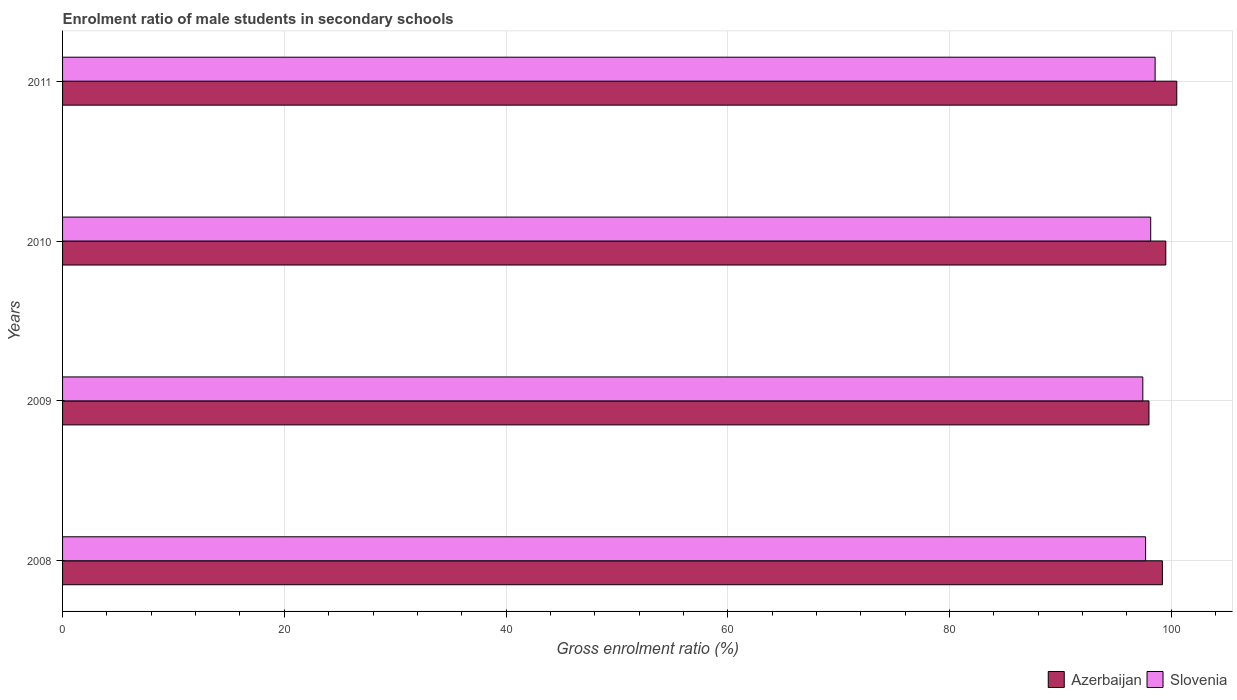How many different coloured bars are there?
Keep it short and to the point. 2. How many groups of bars are there?
Provide a succinct answer. 4. How many bars are there on the 3rd tick from the bottom?
Offer a terse response. 2. What is the label of the 4th group of bars from the top?
Offer a very short reply. 2008. What is the enrolment ratio of male students in secondary schools in Slovenia in 2010?
Offer a very short reply. 98.15. Across all years, what is the maximum enrolment ratio of male students in secondary schools in Slovenia?
Provide a short and direct response. 98.54. Across all years, what is the minimum enrolment ratio of male students in secondary schools in Slovenia?
Your response must be concise. 97.43. In which year was the enrolment ratio of male students in secondary schools in Slovenia maximum?
Offer a very short reply. 2011. What is the total enrolment ratio of male students in secondary schools in Slovenia in the graph?
Make the answer very short. 391.81. What is the difference between the enrolment ratio of male students in secondary schools in Azerbaijan in 2009 and that in 2011?
Give a very brief answer. -2.51. What is the difference between the enrolment ratio of male students in secondary schools in Slovenia in 2010 and the enrolment ratio of male students in secondary schools in Azerbaijan in 2009?
Your response must be concise. 0.16. What is the average enrolment ratio of male students in secondary schools in Azerbaijan per year?
Offer a very short reply. 99.3. In the year 2008, what is the difference between the enrolment ratio of male students in secondary schools in Azerbaijan and enrolment ratio of male students in secondary schools in Slovenia?
Offer a very short reply. 1.51. In how many years, is the enrolment ratio of male students in secondary schools in Azerbaijan greater than 4 %?
Your answer should be very brief. 4. What is the ratio of the enrolment ratio of male students in secondary schools in Azerbaijan in 2009 to that in 2011?
Offer a terse response. 0.98. Is the enrolment ratio of male students in secondary schools in Slovenia in 2009 less than that in 2011?
Give a very brief answer. Yes. What is the difference between the highest and the second highest enrolment ratio of male students in secondary schools in Slovenia?
Your answer should be very brief. 0.4. What is the difference between the highest and the lowest enrolment ratio of male students in secondary schools in Slovenia?
Keep it short and to the point. 1.11. In how many years, is the enrolment ratio of male students in secondary schools in Slovenia greater than the average enrolment ratio of male students in secondary schools in Slovenia taken over all years?
Provide a succinct answer. 2. Is the sum of the enrolment ratio of male students in secondary schools in Azerbaijan in 2009 and 2010 greater than the maximum enrolment ratio of male students in secondary schools in Slovenia across all years?
Your response must be concise. Yes. What does the 2nd bar from the top in 2008 represents?
Give a very brief answer. Azerbaijan. What does the 2nd bar from the bottom in 2008 represents?
Make the answer very short. Slovenia. How many bars are there?
Offer a terse response. 8. What is the difference between two consecutive major ticks on the X-axis?
Offer a terse response. 20. Does the graph contain grids?
Provide a short and direct response. Yes. Where does the legend appear in the graph?
Make the answer very short. Bottom right. What is the title of the graph?
Offer a very short reply. Enrolment ratio of male students in secondary schools. Does "Lebanon" appear as one of the legend labels in the graph?
Your answer should be compact. No. What is the Gross enrolment ratio (%) of Azerbaijan in 2008?
Ensure brevity in your answer.  99.2. What is the Gross enrolment ratio (%) in Slovenia in 2008?
Provide a succinct answer. 97.69. What is the Gross enrolment ratio (%) in Azerbaijan in 2009?
Provide a short and direct response. 97.99. What is the Gross enrolment ratio (%) of Slovenia in 2009?
Offer a very short reply. 97.43. What is the Gross enrolment ratio (%) of Azerbaijan in 2010?
Offer a terse response. 99.51. What is the Gross enrolment ratio (%) in Slovenia in 2010?
Your response must be concise. 98.15. What is the Gross enrolment ratio (%) of Azerbaijan in 2011?
Give a very brief answer. 100.5. What is the Gross enrolment ratio (%) in Slovenia in 2011?
Offer a very short reply. 98.54. Across all years, what is the maximum Gross enrolment ratio (%) of Azerbaijan?
Your response must be concise. 100.5. Across all years, what is the maximum Gross enrolment ratio (%) of Slovenia?
Ensure brevity in your answer.  98.54. Across all years, what is the minimum Gross enrolment ratio (%) of Azerbaijan?
Provide a succinct answer. 97.99. Across all years, what is the minimum Gross enrolment ratio (%) of Slovenia?
Make the answer very short. 97.43. What is the total Gross enrolment ratio (%) of Azerbaijan in the graph?
Make the answer very short. 397.2. What is the total Gross enrolment ratio (%) in Slovenia in the graph?
Offer a terse response. 391.81. What is the difference between the Gross enrolment ratio (%) of Azerbaijan in 2008 and that in 2009?
Ensure brevity in your answer.  1.21. What is the difference between the Gross enrolment ratio (%) in Slovenia in 2008 and that in 2009?
Your response must be concise. 0.25. What is the difference between the Gross enrolment ratio (%) of Azerbaijan in 2008 and that in 2010?
Keep it short and to the point. -0.31. What is the difference between the Gross enrolment ratio (%) in Slovenia in 2008 and that in 2010?
Keep it short and to the point. -0.46. What is the difference between the Gross enrolment ratio (%) in Azerbaijan in 2008 and that in 2011?
Ensure brevity in your answer.  -1.3. What is the difference between the Gross enrolment ratio (%) of Slovenia in 2008 and that in 2011?
Your answer should be very brief. -0.86. What is the difference between the Gross enrolment ratio (%) of Azerbaijan in 2009 and that in 2010?
Provide a short and direct response. -1.52. What is the difference between the Gross enrolment ratio (%) of Slovenia in 2009 and that in 2010?
Provide a succinct answer. -0.71. What is the difference between the Gross enrolment ratio (%) of Azerbaijan in 2009 and that in 2011?
Offer a very short reply. -2.51. What is the difference between the Gross enrolment ratio (%) of Slovenia in 2009 and that in 2011?
Offer a terse response. -1.11. What is the difference between the Gross enrolment ratio (%) of Azerbaijan in 2010 and that in 2011?
Ensure brevity in your answer.  -0.99. What is the difference between the Gross enrolment ratio (%) of Slovenia in 2010 and that in 2011?
Offer a terse response. -0.4. What is the difference between the Gross enrolment ratio (%) of Azerbaijan in 2008 and the Gross enrolment ratio (%) of Slovenia in 2009?
Make the answer very short. 1.77. What is the difference between the Gross enrolment ratio (%) of Azerbaijan in 2008 and the Gross enrolment ratio (%) of Slovenia in 2010?
Make the answer very short. 1.05. What is the difference between the Gross enrolment ratio (%) of Azerbaijan in 2008 and the Gross enrolment ratio (%) of Slovenia in 2011?
Your answer should be compact. 0.66. What is the difference between the Gross enrolment ratio (%) of Azerbaijan in 2009 and the Gross enrolment ratio (%) of Slovenia in 2010?
Keep it short and to the point. -0.16. What is the difference between the Gross enrolment ratio (%) in Azerbaijan in 2009 and the Gross enrolment ratio (%) in Slovenia in 2011?
Your answer should be very brief. -0.55. What is the difference between the Gross enrolment ratio (%) of Azerbaijan in 2010 and the Gross enrolment ratio (%) of Slovenia in 2011?
Ensure brevity in your answer.  0.96. What is the average Gross enrolment ratio (%) of Azerbaijan per year?
Keep it short and to the point. 99.3. What is the average Gross enrolment ratio (%) of Slovenia per year?
Offer a very short reply. 97.95. In the year 2008, what is the difference between the Gross enrolment ratio (%) of Azerbaijan and Gross enrolment ratio (%) of Slovenia?
Provide a succinct answer. 1.51. In the year 2009, what is the difference between the Gross enrolment ratio (%) in Azerbaijan and Gross enrolment ratio (%) in Slovenia?
Provide a short and direct response. 0.56. In the year 2010, what is the difference between the Gross enrolment ratio (%) of Azerbaijan and Gross enrolment ratio (%) of Slovenia?
Your answer should be very brief. 1.36. In the year 2011, what is the difference between the Gross enrolment ratio (%) in Azerbaijan and Gross enrolment ratio (%) in Slovenia?
Provide a short and direct response. 1.95. What is the ratio of the Gross enrolment ratio (%) in Azerbaijan in 2008 to that in 2009?
Ensure brevity in your answer.  1.01. What is the ratio of the Gross enrolment ratio (%) in Slovenia in 2008 to that in 2009?
Offer a very short reply. 1. What is the ratio of the Gross enrolment ratio (%) in Azerbaijan in 2008 to that in 2011?
Provide a succinct answer. 0.99. What is the ratio of the Gross enrolment ratio (%) of Azerbaijan in 2009 to that in 2010?
Ensure brevity in your answer.  0.98. What is the ratio of the Gross enrolment ratio (%) of Azerbaijan in 2009 to that in 2011?
Your answer should be very brief. 0.97. What is the ratio of the Gross enrolment ratio (%) of Slovenia in 2009 to that in 2011?
Your response must be concise. 0.99. What is the difference between the highest and the second highest Gross enrolment ratio (%) in Azerbaijan?
Offer a very short reply. 0.99. What is the difference between the highest and the second highest Gross enrolment ratio (%) in Slovenia?
Make the answer very short. 0.4. What is the difference between the highest and the lowest Gross enrolment ratio (%) of Azerbaijan?
Your answer should be very brief. 2.51. What is the difference between the highest and the lowest Gross enrolment ratio (%) of Slovenia?
Give a very brief answer. 1.11. 